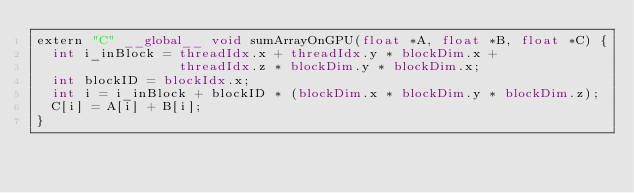<code> <loc_0><loc_0><loc_500><loc_500><_Cuda_>extern "C" __global__ void sumArrayOnGPU(float *A, float *B, float *C) {
  int i_inBlock = threadIdx.x + threadIdx.y * blockDim.x +
                  threadIdx.z * blockDim.y * blockDim.x;
  int blockID = blockIdx.x;
  int i = i_inBlock + blockID * (blockDim.x * blockDim.y * blockDim.z);
  C[i] = A[i] + B[i];
}</code> 